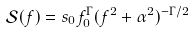Convert formula to latex. <formula><loc_0><loc_0><loc_500><loc_500>\mathcal { S } ( f ) = s _ { 0 } f _ { 0 } ^ { \Gamma } ( f ^ { 2 } + \alpha ^ { 2 } ) ^ { - \Gamma / 2 }</formula> 